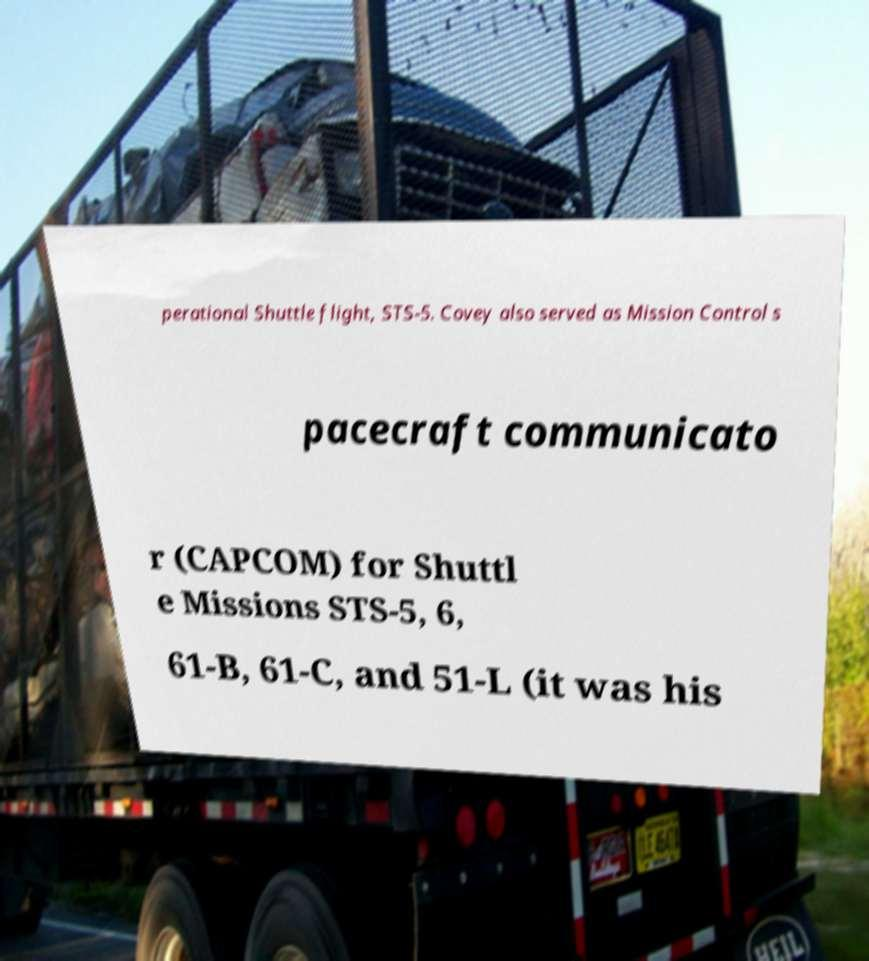There's text embedded in this image that I need extracted. Can you transcribe it verbatim? perational Shuttle flight, STS-5. Covey also served as Mission Control s pacecraft communicato r (CAPCOM) for Shuttl e Missions STS-5, 6, 61-B, 61-C, and 51-L (it was his 